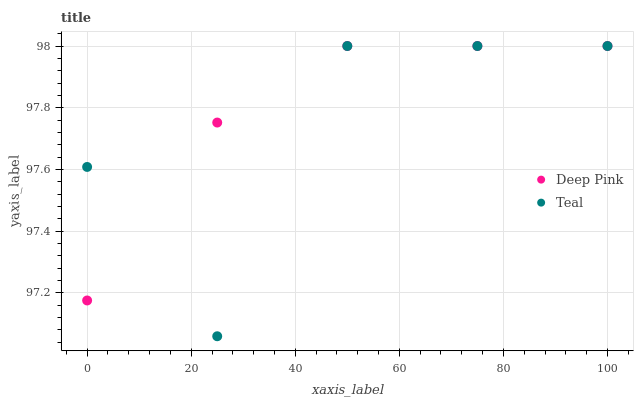Does Teal have the minimum area under the curve?
Answer yes or no. Yes. Does Deep Pink have the maximum area under the curve?
Answer yes or no. Yes. Does Teal have the maximum area under the curve?
Answer yes or no. No. Is Deep Pink the smoothest?
Answer yes or no. Yes. Is Teal the roughest?
Answer yes or no. Yes. Is Teal the smoothest?
Answer yes or no. No. Does Teal have the lowest value?
Answer yes or no. Yes. Does Teal have the highest value?
Answer yes or no. Yes. Does Deep Pink intersect Teal?
Answer yes or no. Yes. Is Deep Pink less than Teal?
Answer yes or no. No. Is Deep Pink greater than Teal?
Answer yes or no. No. 